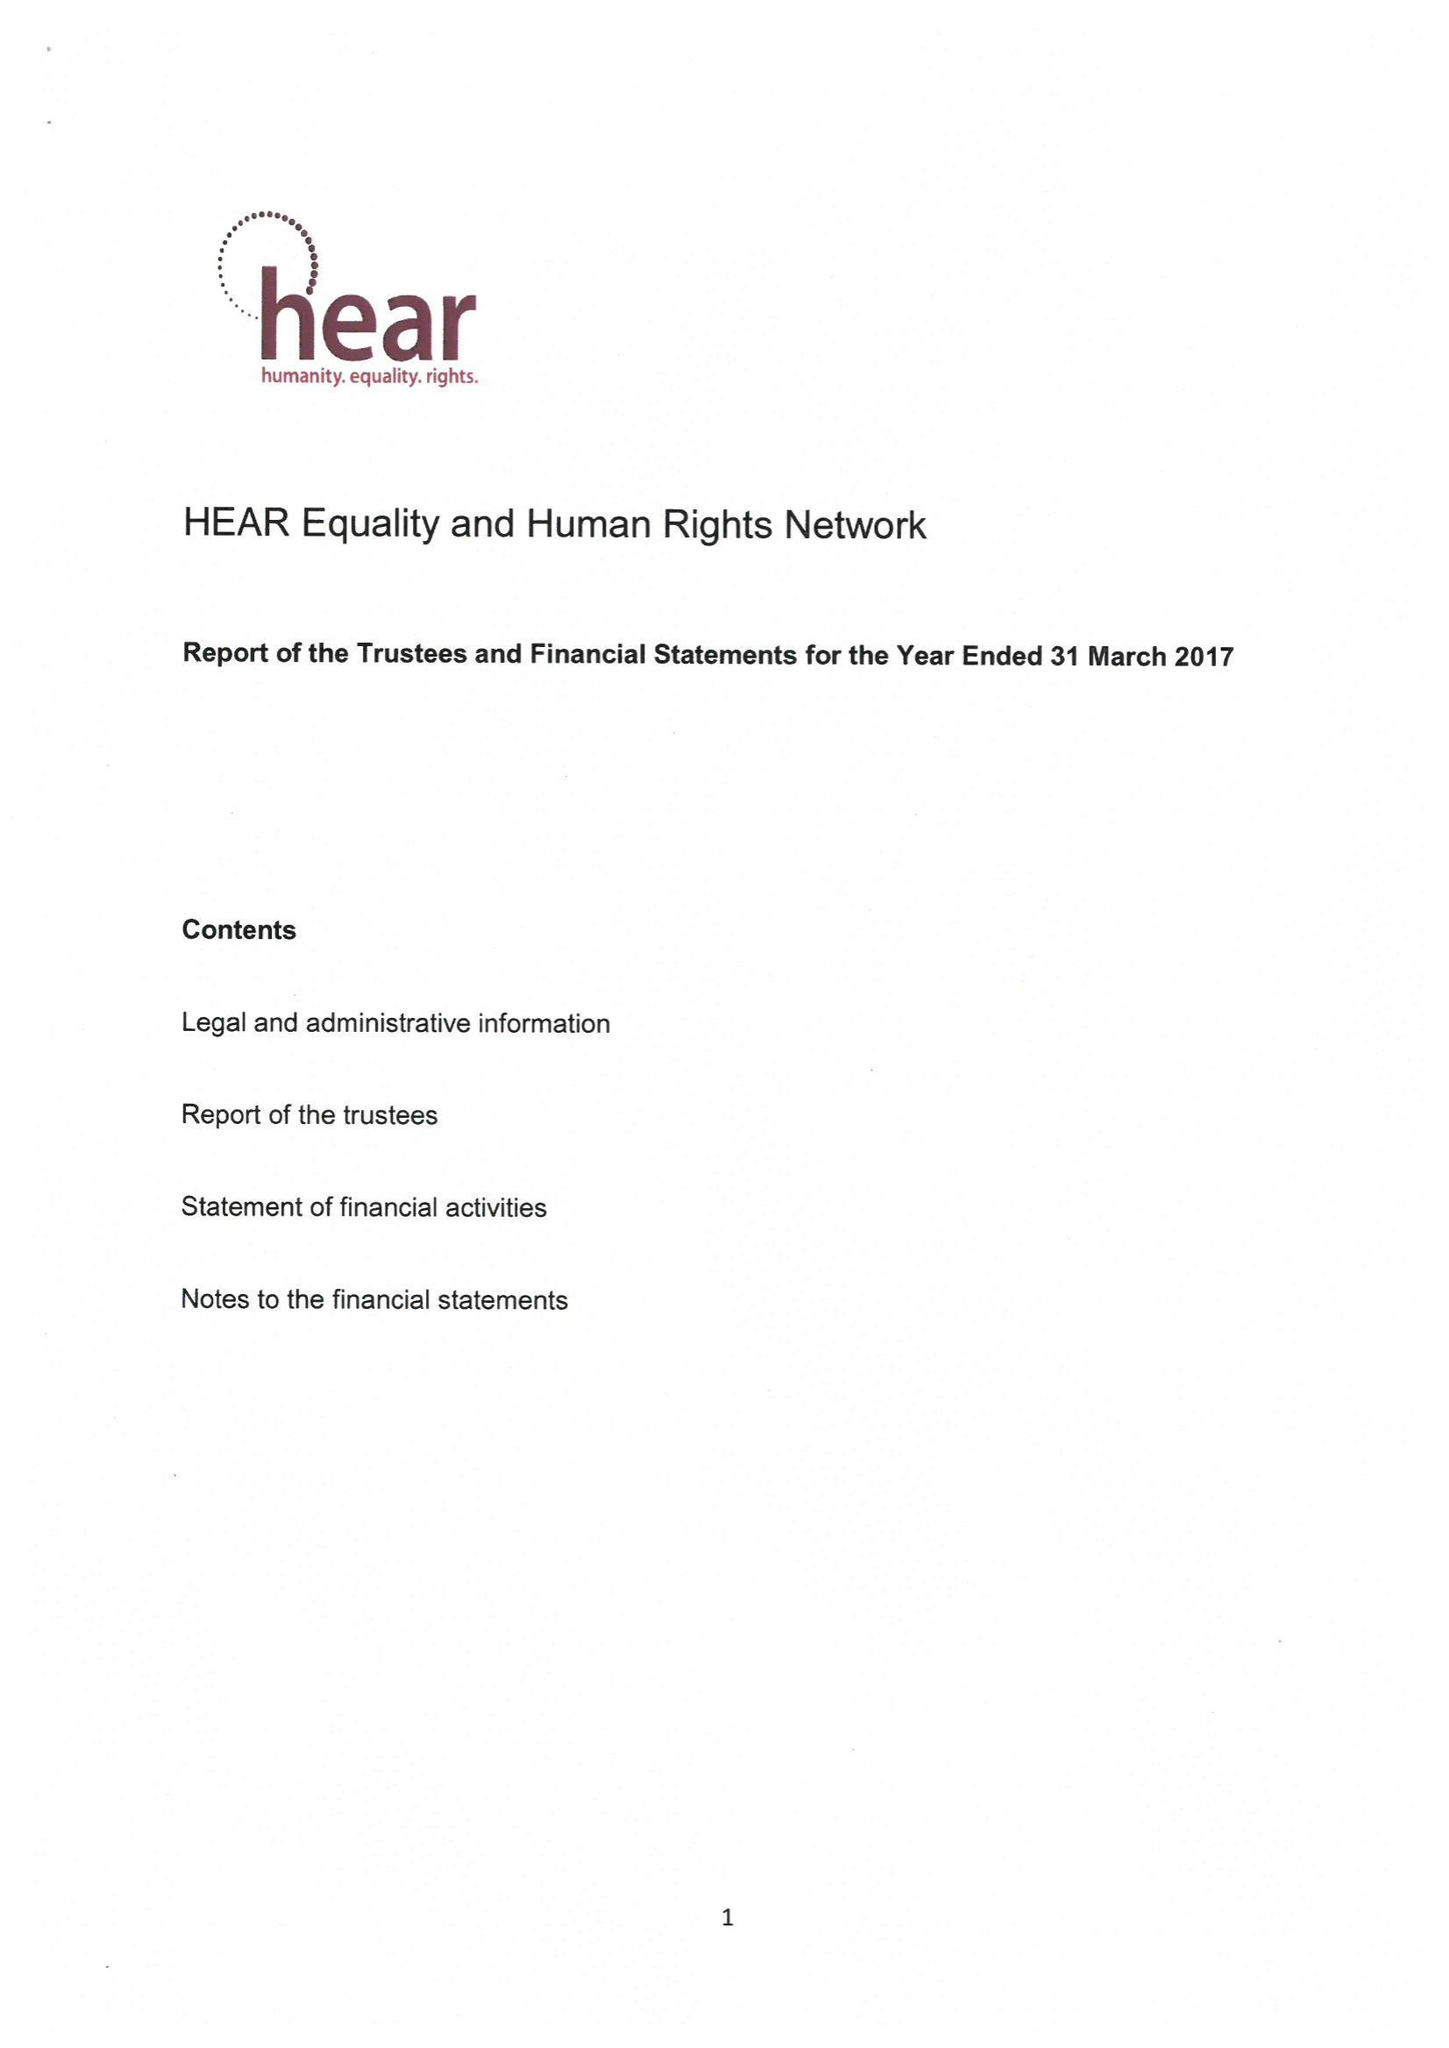What is the value for the report_date?
Answer the question using a single word or phrase. 2017-03-31 